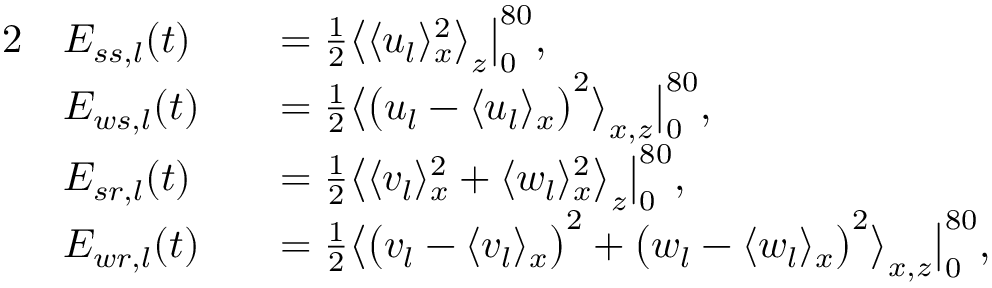<formula> <loc_0><loc_0><loc_500><loc_500>\begin{array} { r l r l } { 2 } & { E _ { s s , l } ( t ) } & & { = \frac { 1 } { 2 } \left \langle \langle u _ { l } \rangle _ { x } ^ { 2 } \right \rangle _ { z } \left | _ { 0 } ^ { 8 0 } , } \\ & { E _ { w s , l } ( t ) } & & { = \frac { 1 } { 2 } \left \langle \left ( u _ { l } - \langle u _ { l } \rangle _ { x } \right ) ^ { 2 } \right \rangle _ { x , z } \right | _ { 0 } ^ { 8 0 } , } \\ & { E _ { s r , l } ( t ) } & & { = \frac { 1 } { 2 } \left \langle \langle v _ { l } \rangle _ { x } ^ { 2 } + \langle w _ { l } \rangle _ { x } ^ { 2 } \right \rangle _ { z } \left | _ { 0 } ^ { 8 0 } , } \\ & { E _ { w r , l } ( t ) } & & { = \frac { 1 } { 2 } \left \langle \left ( v _ { l } - \langle v _ { l } \rangle _ { x } \right ) ^ { 2 } + \left ( w _ { l } - \langle w _ { l } \rangle _ { x } \right ) ^ { 2 } \right \rangle _ { x , z } \right | _ { 0 } ^ { 8 0 } , } \end{array}</formula> 